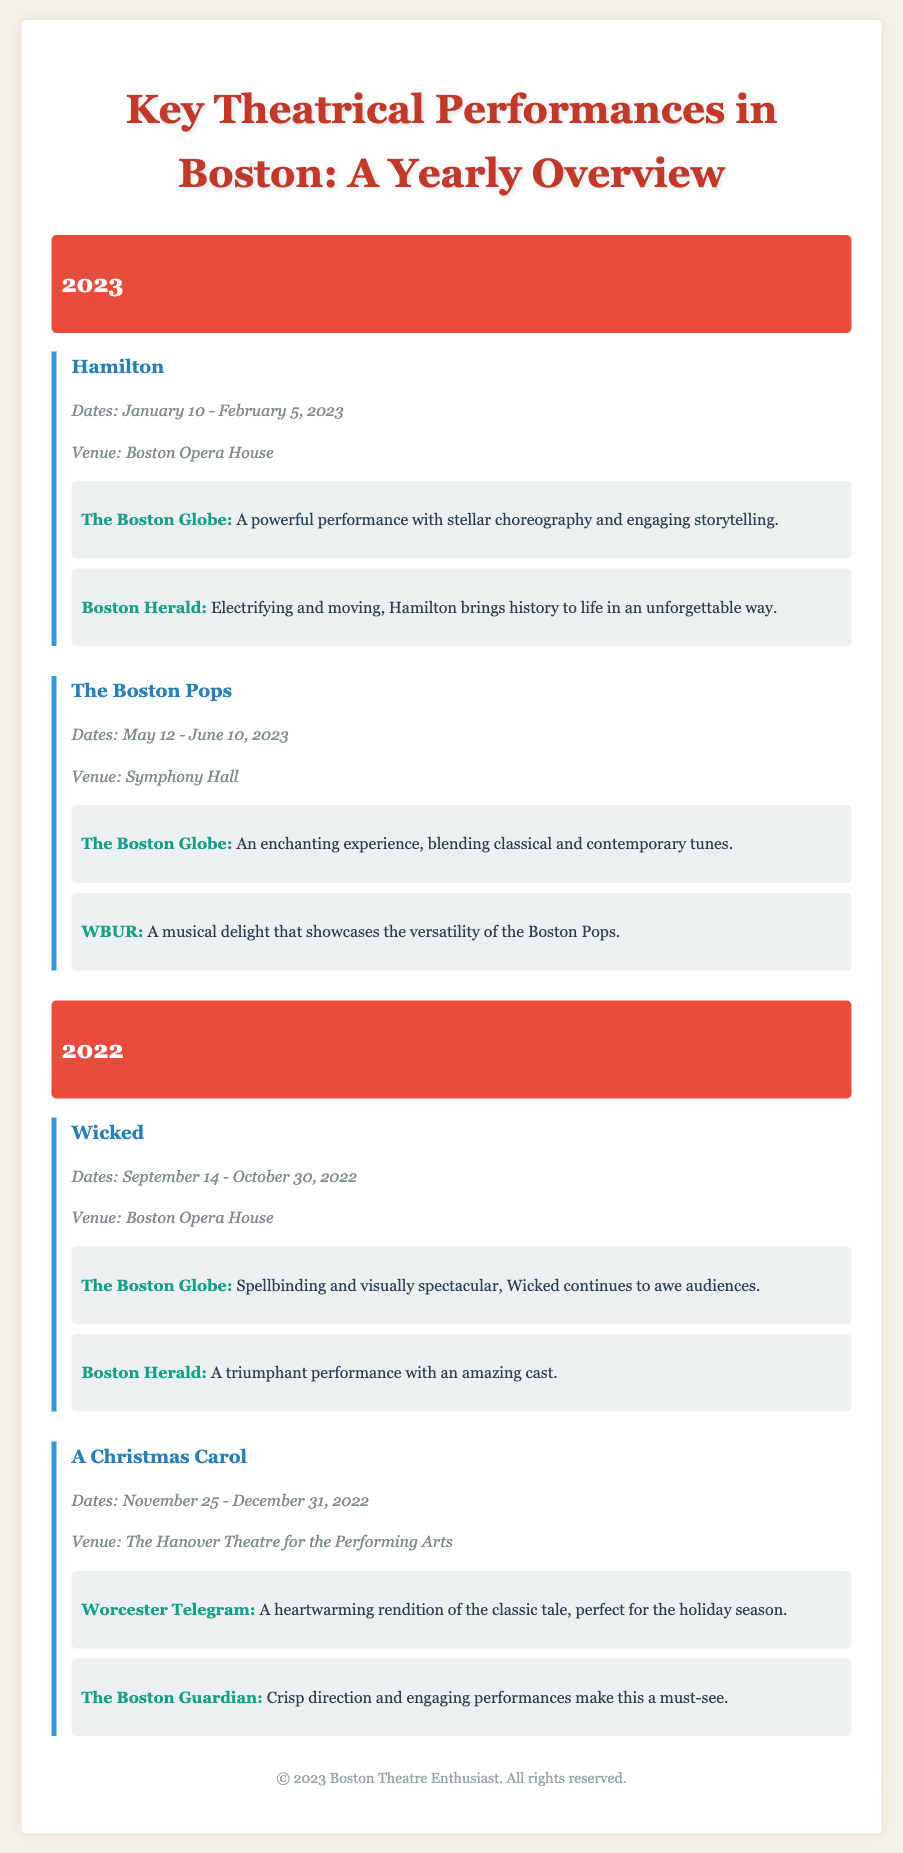What is the title of the performance that ran from January 10 to February 5, 2023? The title can be found within the performance details for that date range.
Answer: Hamilton What venue hosted "Wicked"? The venue information is listed under the details of the performance "Wicked".
Answer: Boston Opera House Which performance occurred between May 12 and June 10, 2023? This performance can be determined by reviewing the date details in the document.
Answer: The Boston Pops What is one source that reviewed "Hamilton"? The document provides reviews by specific sources which can be identified per performance.
Answer: The Boston Globe How long did "A Christmas Carol" run? The duration of the performance can be calculated by subtracting the start date from the end date listed in the details.
Answer: 37 days What color is the background of the year headings? The color for these sections is indicated in the document styles for the year headings.
Answer: Red Which year had performances at the Boston Opera House? This can be determined by checking the venue details for each performance in the relevant year sections.
Answer: 2023 and 2022 How many reviews are listed for "Wicked"? The number of reviews can be tallied by counting the review entries under that performance.
Answer: 2 